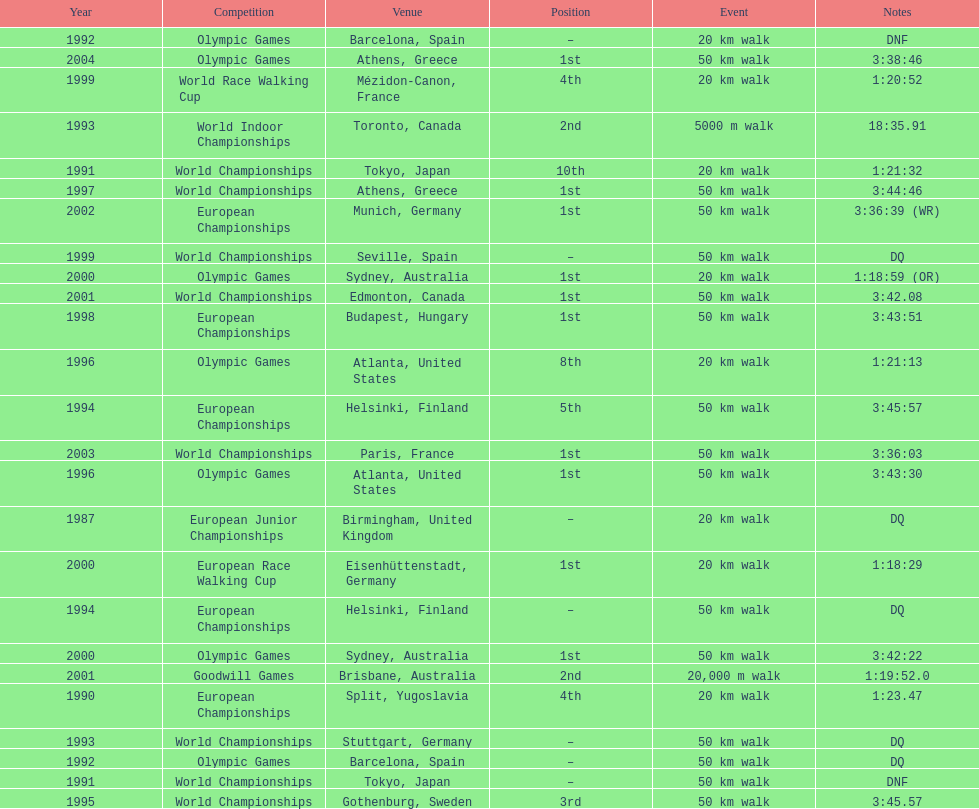How many times was korzeniowski disqualified from a competition? 5. 